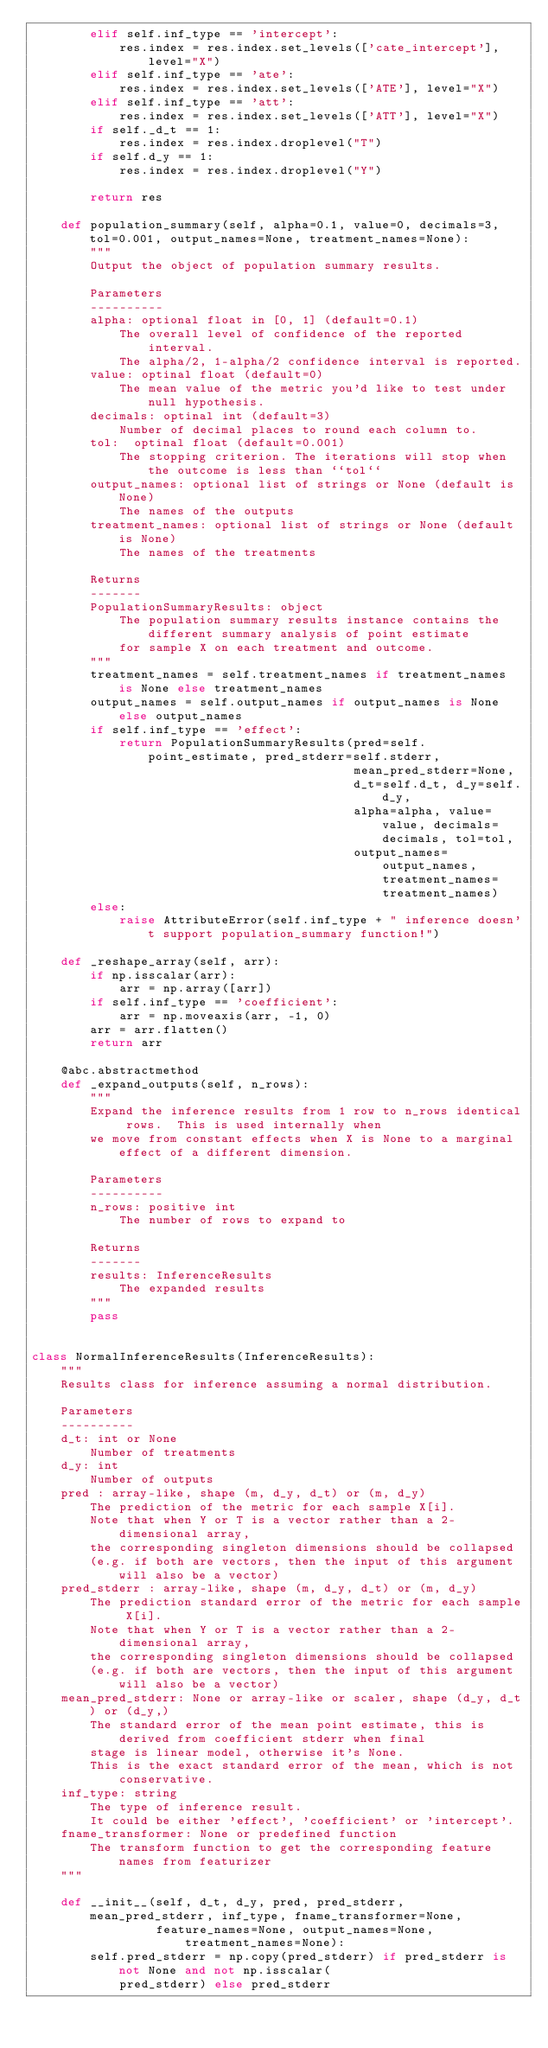<code> <loc_0><loc_0><loc_500><loc_500><_Python_>        elif self.inf_type == 'intercept':
            res.index = res.index.set_levels(['cate_intercept'], level="X")
        elif self.inf_type == 'ate':
            res.index = res.index.set_levels(['ATE'], level="X")
        elif self.inf_type == 'att':
            res.index = res.index.set_levels(['ATT'], level="X")
        if self._d_t == 1:
            res.index = res.index.droplevel("T")
        if self.d_y == 1:
            res.index = res.index.droplevel("Y")

        return res

    def population_summary(self, alpha=0.1, value=0, decimals=3, tol=0.001, output_names=None, treatment_names=None):
        """
        Output the object of population summary results.

        Parameters
        ----------
        alpha: optional float in [0, 1] (default=0.1)
            The overall level of confidence of the reported interval.
            The alpha/2, 1-alpha/2 confidence interval is reported.
        value: optinal float (default=0)
            The mean value of the metric you'd like to test under null hypothesis.
        decimals: optinal int (default=3)
            Number of decimal places to round each column to.
        tol:  optinal float (default=0.001)
            The stopping criterion. The iterations will stop when the outcome is less than ``tol``
        output_names: optional list of strings or None (default is None)
            The names of the outputs
        treatment_names: optional list of strings or None (default is None)
            The names of the treatments

        Returns
        -------
        PopulationSummaryResults: object
            The population summary results instance contains the different summary analysis of point estimate
            for sample X on each treatment and outcome.
        """
        treatment_names = self.treatment_names if treatment_names is None else treatment_names
        output_names = self.output_names if output_names is None else output_names
        if self.inf_type == 'effect':
            return PopulationSummaryResults(pred=self.point_estimate, pred_stderr=self.stderr,
                                            mean_pred_stderr=None,
                                            d_t=self.d_t, d_y=self.d_y,
                                            alpha=alpha, value=value, decimals=decimals, tol=tol,
                                            output_names=output_names, treatment_names=treatment_names)
        else:
            raise AttributeError(self.inf_type + " inference doesn't support population_summary function!")

    def _reshape_array(self, arr):
        if np.isscalar(arr):
            arr = np.array([arr])
        if self.inf_type == 'coefficient':
            arr = np.moveaxis(arr, -1, 0)
        arr = arr.flatten()
        return arr

    @abc.abstractmethod
    def _expand_outputs(self, n_rows):
        """
        Expand the inference results from 1 row to n_rows identical rows.  This is used internally when
        we move from constant effects when X is None to a marginal effect of a different dimension.

        Parameters
        ----------
        n_rows: positive int
            The number of rows to expand to

        Returns
        -------
        results: InferenceResults
            The expanded results
        """
        pass


class NormalInferenceResults(InferenceResults):
    """
    Results class for inference assuming a normal distribution.

    Parameters
    ----------
    d_t: int or None
        Number of treatments
    d_y: int
        Number of outputs
    pred : array-like, shape (m, d_y, d_t) or (m, d_y)
        The prediction of the metric for each sample X[i].
        Note that when Y or T is a vector rather than a 2-dimensional array,
        the corresponding singleton dimensions should be collapsed
        (e.g. if both are vectors, then the input of this argument will also be a vector)
    pred_stderr : array-like, shape (m, d_y, d_t) or (m, d_y)
        The prediction standard error of the metric for each sample X[i].
        Note that when Y or T is a vector rather than a 2-dimensional array,
        the corresponding singleton dimensions should be collapsed
        (e.g. if both are vectors, then the input of this argument will also be a vector)
    mean_pred_stderr: None or array-like or scaler, shape (d_y, d_t) or (d_y,)
        The standard error of the mean point estimate, this is derived from coefficient stderr when final
        stage is linear model, otherwise it's None.
        This is the exact standard error of the mean, which is not conservative.
    inf_type: string
        The type of inference result.
        It could be either 'effect', 'coefficient' or 'intercept'.
    fname_transformer: None or predefined function
        The transform function to get the corresponding feature names from featurizer
    """

    def __init__(self, d_t, d_y, pred, pred_stderr, mean_pred_stderr, inf_type, fname_transformer=None,
                 feature_names=None, output_names=None, treatment_names=None):
        self.pred_stderr = np.copy(pred_stderr) if pred_stderr is not None and not np.isscalar(
            pred_stderr) else pred_stderr</code> 